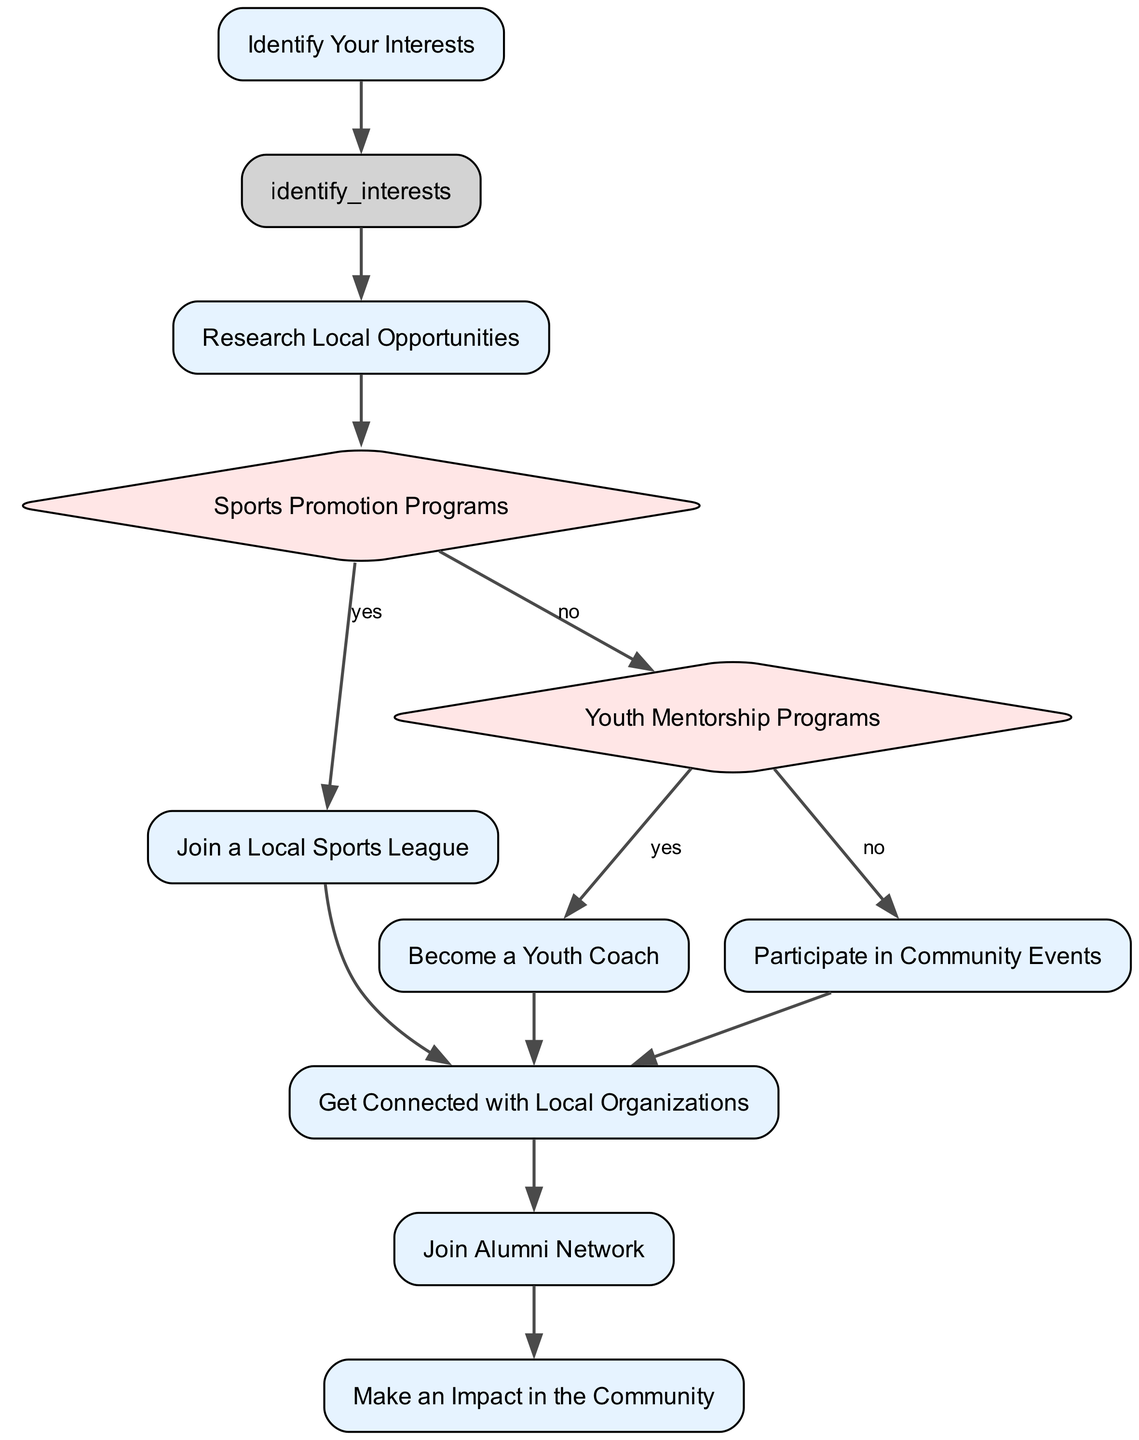What is the first step in the flowchart? The flowchart starts with the node labeled "Identify Your Interests," which is the initial process step all participants must take to begin their volunteering journey.
Answer: Identify Your Interests How many decision nodes are present in the diagram? The diagram contains three decision nodes: "Sports Promotion Programs," "Youth Mentorship Programs," and a decision about what to do next after researching opportunities.
Answer: 3 What happens if someone chooses "no" at the "Sports Promotion Programs" decision? If "no" is selected at the "Sports Promotion Programs" decision, the flowchart directs to "Youth Mentorship Programs," leading to further opportunities in youth mentorship.
Answer: Youth Mentorship Programs What is the action taken after joining a local sports league? After joining a local sports league, the next step as indicated in the flowchart is to "Get Connected with Local Organizations," facilitating further involvement.
Answer: Get Connected with Local Organizations If one opts out of becoming a youth coach, what is the next possibility in the flowchart? If one chooses "no" at the "Youth Mentorship Programs" decision, they can proceed to "Participate in Community Events" as an alternative option for volunteering.
Answer: Participate in Community Events What is the last process step in the flowchart? The final process step in the flowchart is "Make an Impact in the Community," summarizing the ultimate goal of all previous actions taken in the volunteering journey.
Answer: Make an Impact in the Community Which node follows after "Get Connected"? The "Join Alumni Network" node immediately follows the "Get Connected" node in the flowchart, indicating a step for further engagement with peers.
Answer: Join Alumni Network What is the color of the decision nodes in the flowchart? The decision nodes in the flowchart are represented with a fill color of light red (indicated as #FFE6E6), distinguishing them from process nodes.
Answer: Light red How do you start the volunteering process according to the diagram? The process begins with identifying one’s interests, guiding the individual to tailor their volunteering efforts towards what matters most to them.
Answer: Identify Your Interests 